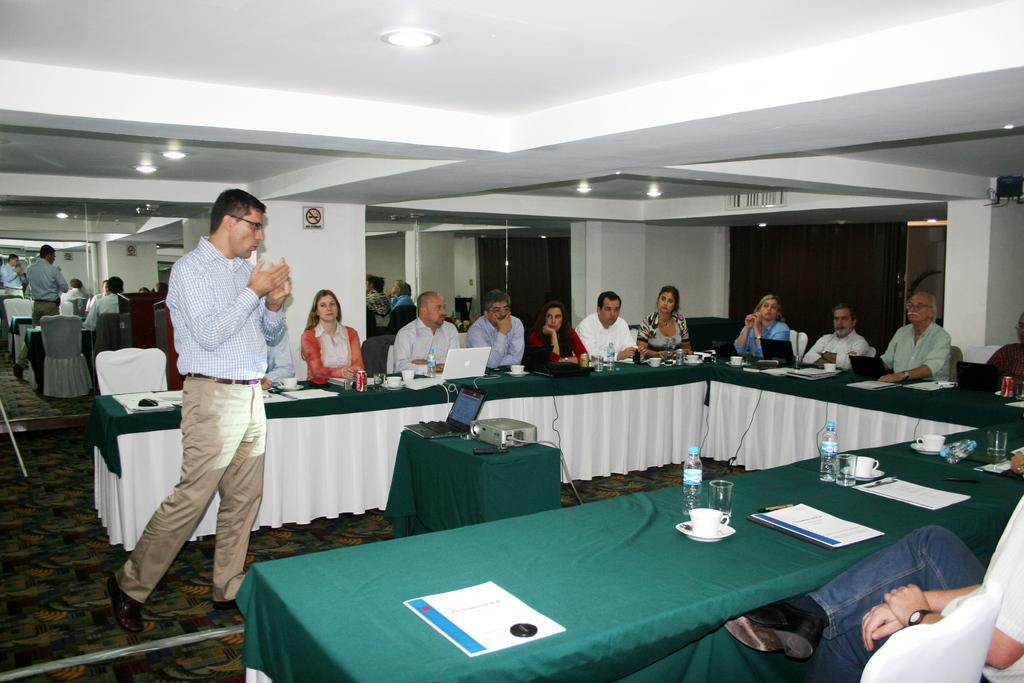Describe this image in one or two sentences. In this picture we can see a group of people, they are sitting on chairs, one person is standing, here we can see tables, laptops, projector, files, bottles, glasses, cups with saucers, coke tins, pens and in the background we can see pillars, roof, lights, mirrors. 